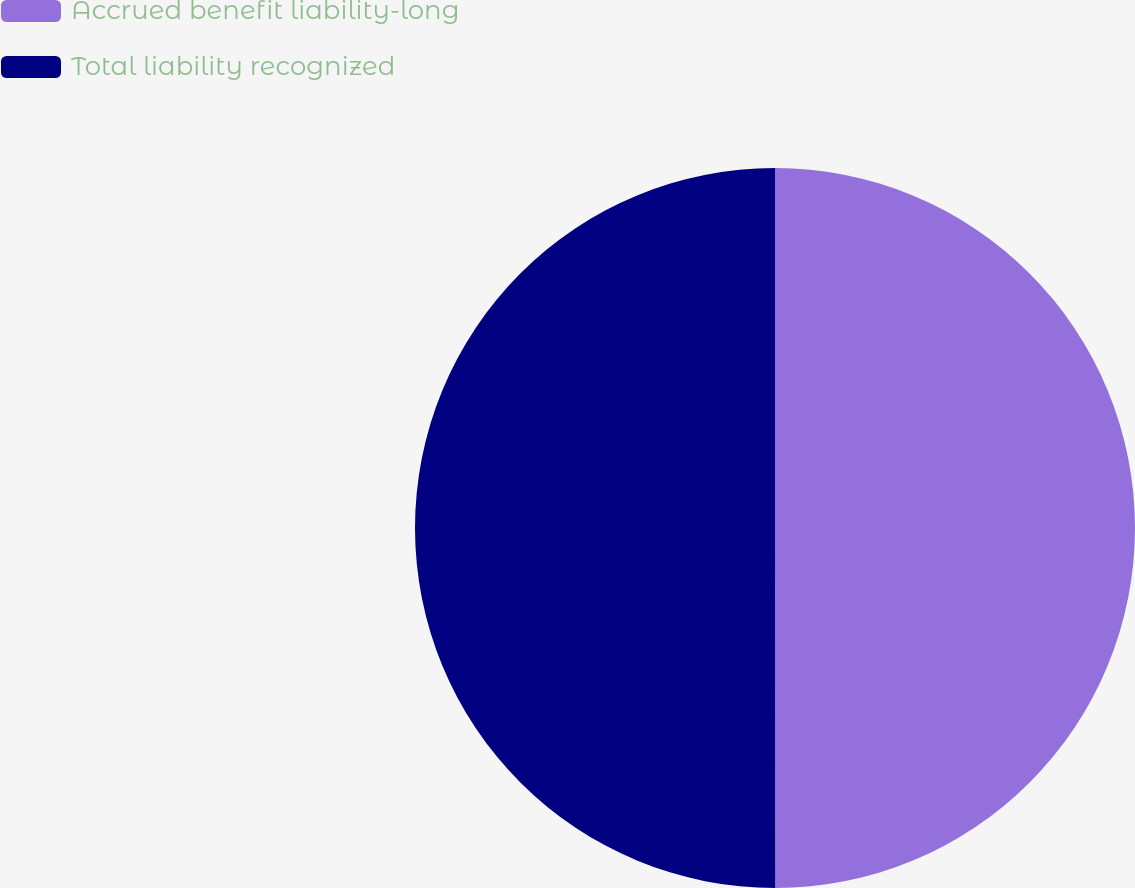Convert chart. <chart><loc_0><loc_0><loc_500><loc_500><pie_chart><fcel>Accrued benefit liability-long<fcel>Total liability recognized<nl><fcel>49.99%<fcel>50.01%<nl></chart> 